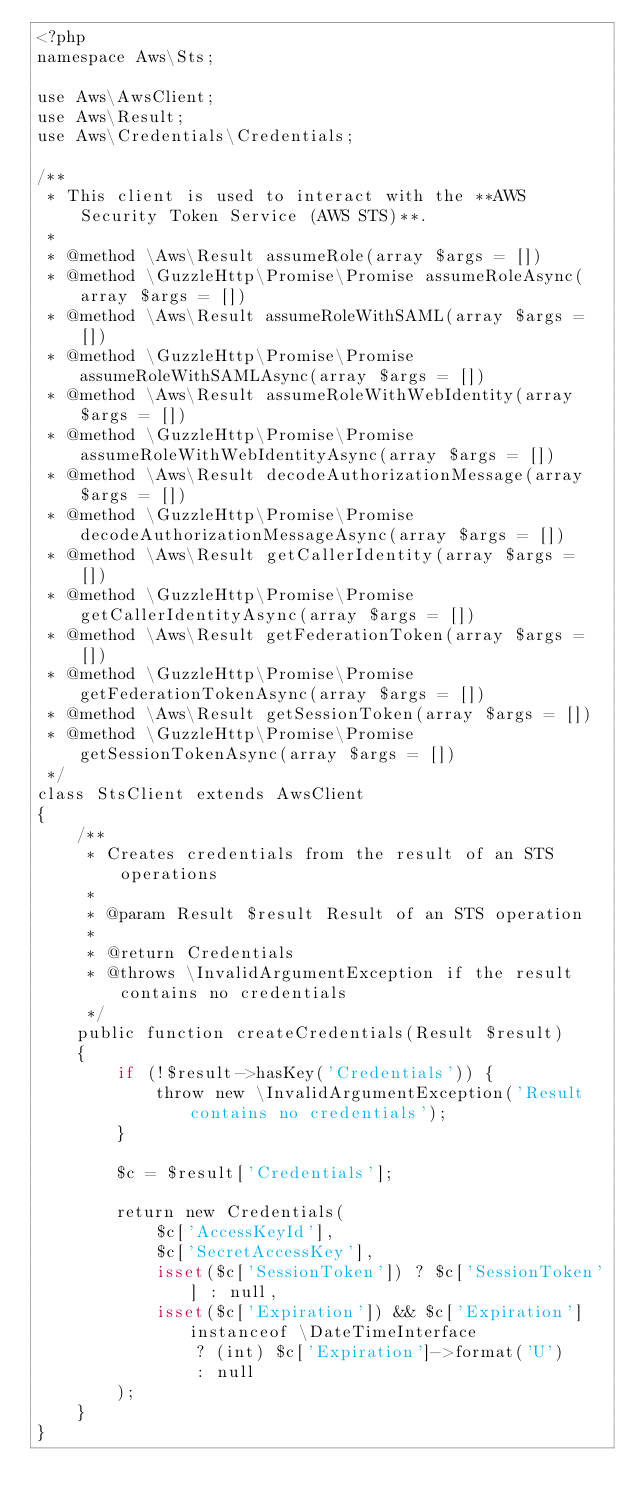<code> <loc_0><loc_0><loc_500><loc_500><_PHP_><?php
namespace Aws\Sts;

use Aws\AwsClient;
use Aws\Result;
use Aws\Credentials\Credentials;

/**
 * This client is used to interact with the **AWS Security Token Service (AWS STS)**.
 *
 * @method \Aws\Result assumeRole(array $args = [])
 * @method \GuzzleHttp\Promise\Promise assumeRoleAsync(array $args = [])
 * @method \Aws\Result assumeRoleWithSAML(array $args = [])
 * @method \GuzzleHttp\Promise\Promise assumeRoleWithSAMLAsync(array $args = [])
 * @method \Aws\Result assumeRoleWithWebIdentity(array $args = [])
 * @method \GuzzleHttp\Promise\Promise assumeRoleWithWebIdentityAsync(array $args = [])
 * @method \Aws\Result decodeAuthorizationMessage(array $args = [])
 * @method \GuzzleHttp\Promise\Promise decodeAuthorizationMessageAsync(array $args = [])
 * @method \Aws\Result getCallerIdentity(array $args = [])
 * @method \GuzzleHttp\Promise\Promise getCallerIdentityAsync(array $args = [])
 * @method \Aws\Result getFederationToken(array $args = [])
 * @method \GuzzleHttp\Promise\Promise getFederationTokenAsync(array $args = [])
 * @method \Aws\Result getSessionToken(array $args = [])
 * @method \GuzzleHttp\Promise\Promise getSessionTokenAsync(array $args = [])
 */
class StsClient extends AwsClient
{
    /**
     * Creates credentials from the result of an STS operations
     *
     * @param Result $result Result of an STS operation
     *
     * @return Credentials
     * @throws \InvalidArgumentException if the result contains no credentials
     */
    public function createCredentials(Result $result)
    {
        if (!$result->hasKey('Credentials')) {
            throw new \InvalidArgumentException('Result contains no credentials');
        }

        $c = $result['Credentials'];

        return new Credentials(
            $c['AccessKeyId'],
            $c['SecretAccessKey'],
            isset($c['SessionToken']) ? $c['SessionToken'] : null,
            isset($c['Expiration']) && $c['Expiration'] instanceof \DateTimeInterface
                ? (int) $c['Expiration']->format('U')
                : null
        );
    }
}
</code> 